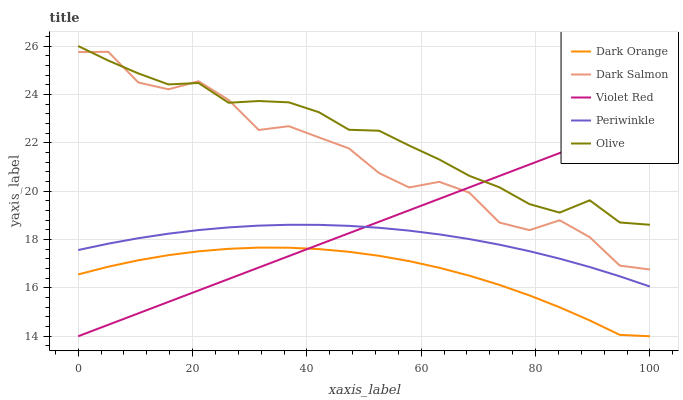Does Dark Orange have the minimum area under the curve?
Answer yes or no. Yes. Does Olive have the maximum area under the curve?
Answer yes or no. Yes. Does Violet Red have the minimum area under the curve?
Answer yes or no. No. Does Violet Red have the maximum area under the curve?
Answer yes or no. No. Is Violet Red the smoothest?
Answer yes or no. Yes. Is Dark Salmon the roughest?
Answer yes or no. Yes. Is Dark Orange the smoothest?
Answer yes or no. No. Is Dark Orange the roughest?
Answer yes or no. No. Does Dark Orange have the lowest value?
Answer yes or no. Yes. Does Periwinkle have the lowest value?
Answer yes or no. No. Does Olive have the highest value?
Answer yes or no. Yes. Does Violet Red have the highest value?
Answer yes or no. No. Is Periwinkle less than Dark Salmon?
Answer yes or no. Yes. Is Olive greater than Dark Orange?
Answer yes or no. Yes. Does Dark Salmon intersect Olive?
Answer yes or no. Yes. Is Dark Salmon less than Olive?
Answer yes or no. No. Is Dark Salmon greater than Olive?
Answer yes or no. No. Does Periwinkle intersect Dark Salmon?
Answer yes or no. No. 